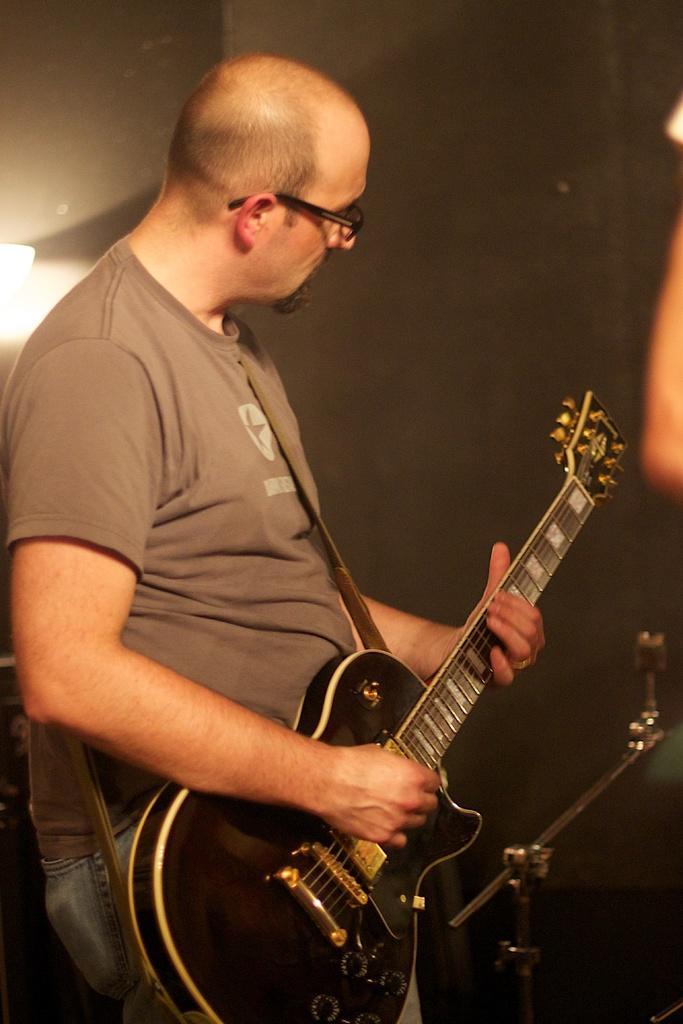Please provide a concise description of this image. The man is standing wore spectacles and playing a guitar 